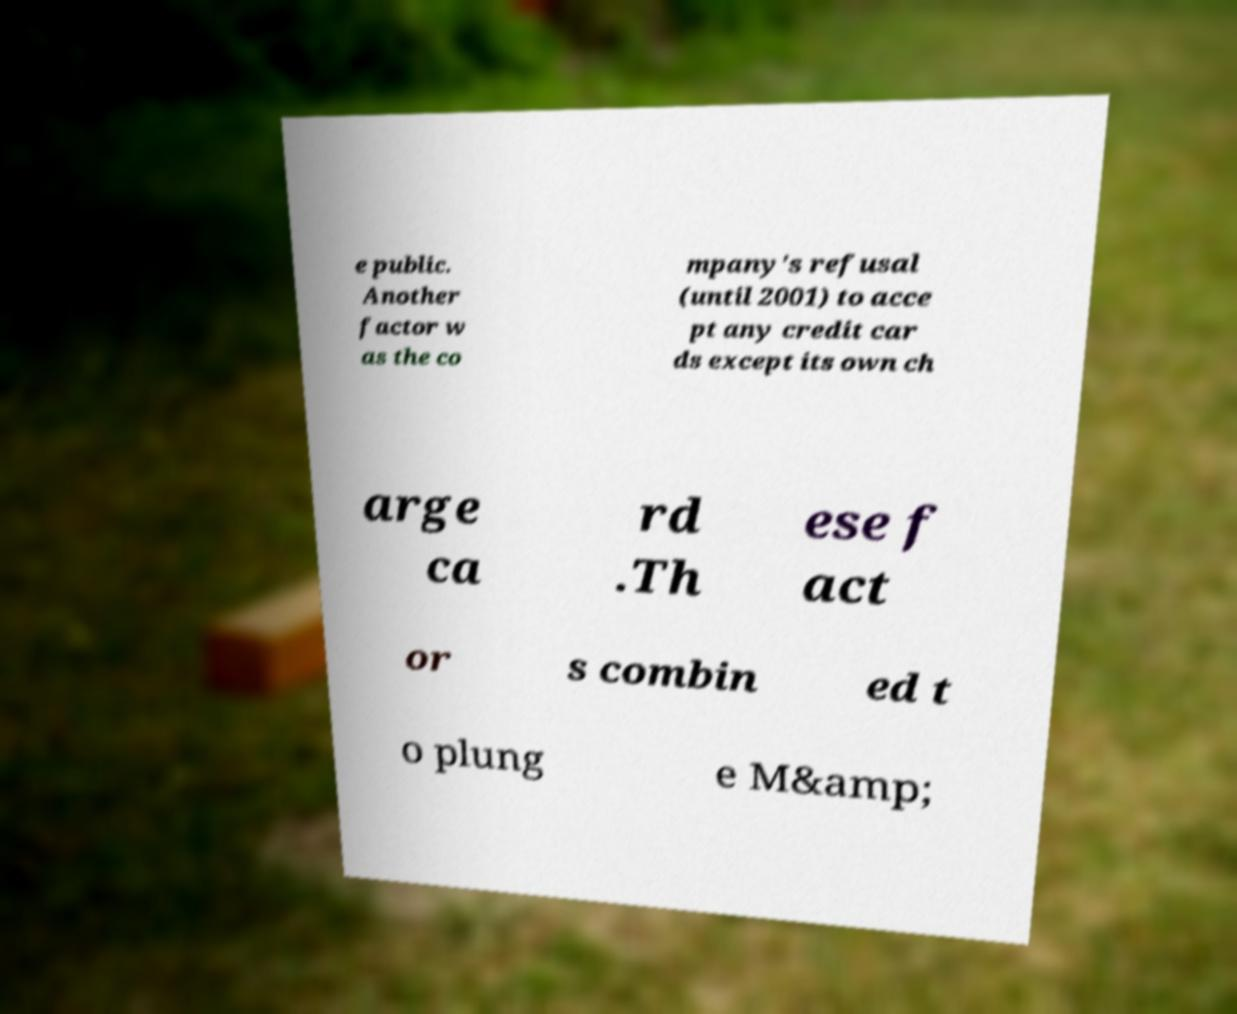There's text embedded in this image that I need extracted. Can you transcribe it verbatim? e public. Another factor w as the co mpany's refusal (until 2001) to acce pt any credit car ds except its own ch arge ca rd .Th ese f act or s combin ed t o plung e M&amp; 